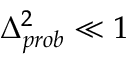<formula> <loc_0><loc_0><loc_500><loc_500>\Delta _ { p r o b } ^ { 2 } \ll 1</formula> 